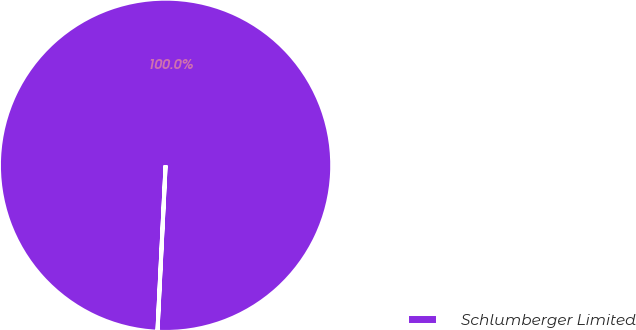<chart> <loc_0><loc_0><loc_500><loc_500><pie_chart><fcel>Schlumberger Limited<nl><fcel>100.0%<nl></chart> 